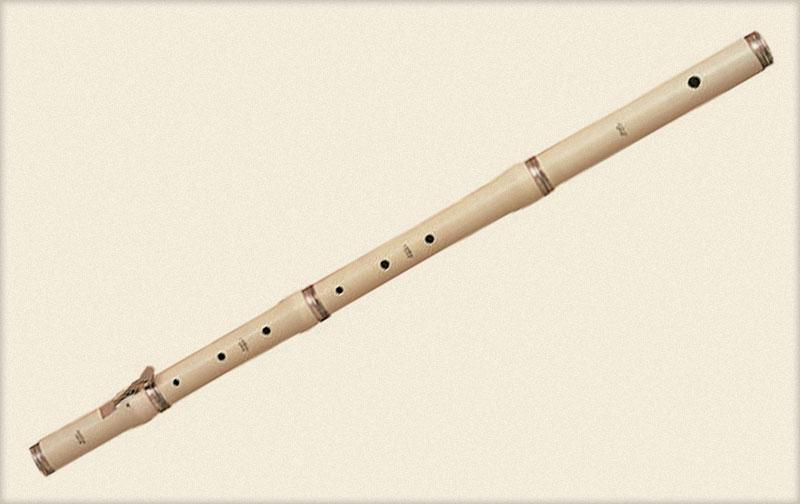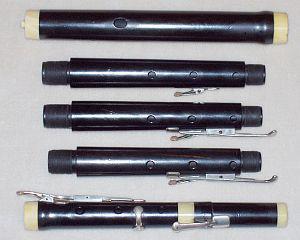The first image is the image on the left, the second image is the image on the right. Examine the images to the left and right. Is the description "Each image contains a single instrument item, and at least one image shows a part with two metal tabs extending around an oblong hole." accurate? Answer yes or no. No. The first image is the image on the left, the second image is the image on the right. Considering the images on both sides, is "The right image contains a single instrument." valid? Answer yes or no. No. 